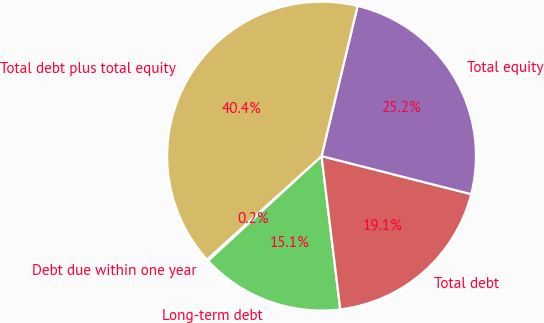Convert chart. <chart><loc_0><loc_0><loc_500><loc_500><pie_chart><fcel>Debt due within one year<fcel>Long-term debt<fcel>Total debt<fcel>Total equity<fcel>Total debt plus total equity<nl><fcel>0.17%<fcel>15.07%<fcel>19.1%<fcel>25.22%<fcel>40.45%<nl></chart> 